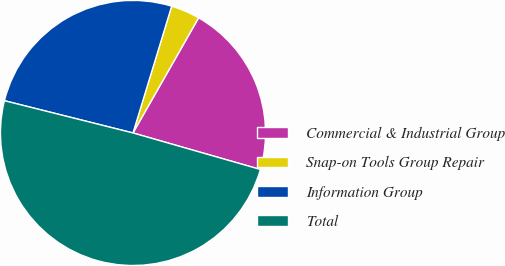Convert chart. <chart><loc_0><loc_0><loc_500><loc_500><pie_chart><fcel>Commercial & Industrial Group<fcel>Snap-on Tools Group Repair<fcel>Information Group<fcel>Total<nl><fcel>21.2%<fcel>3.53%<fcel>25.8%<fcel>49.47%<nl></chart> 